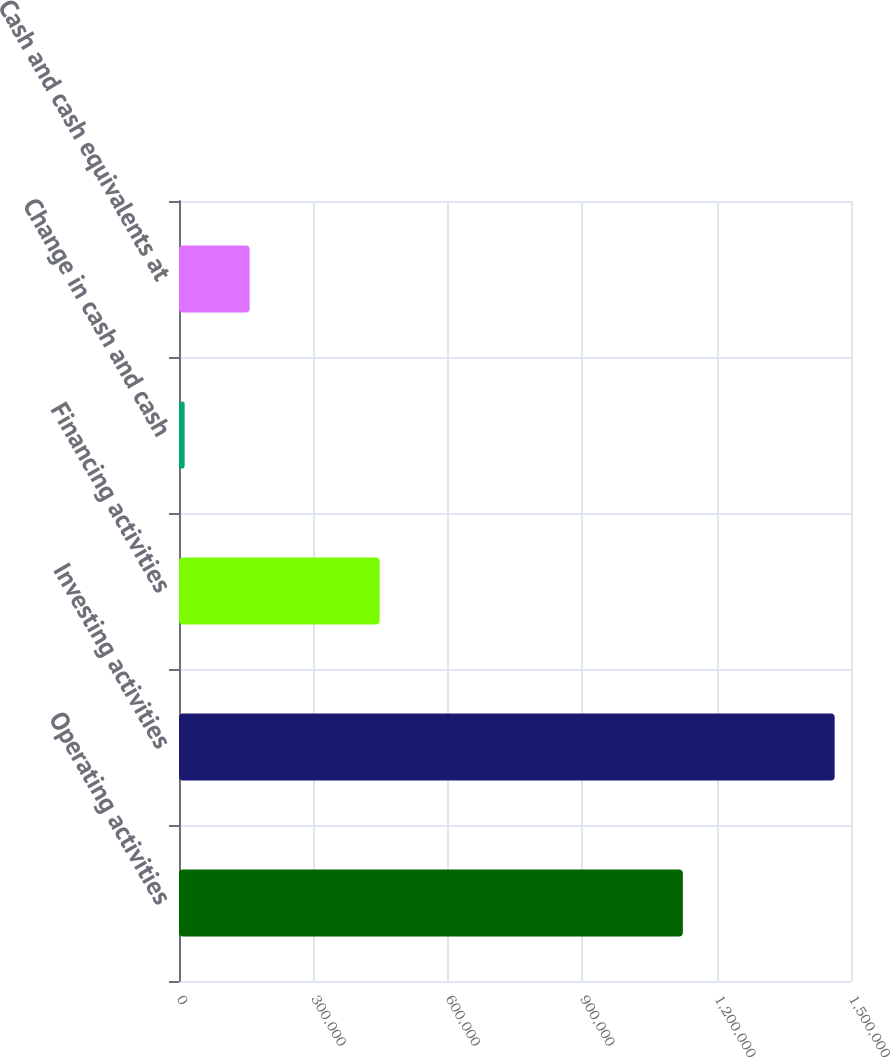Convert chart to OTSL. <chart><loc_0><loc_0><loc_500><loc_500><bar_chart><fcel>Operating activities<fcel>Investing activities<fcel>Financing activities<fcel>Change in cash and cash<fcel>Cash and cash equivalents at<nl><fcel>1.12466e+06<fcel>1.46357e+06<fcel>447916<fcel>12638<fcel>157731<nl></chart> 